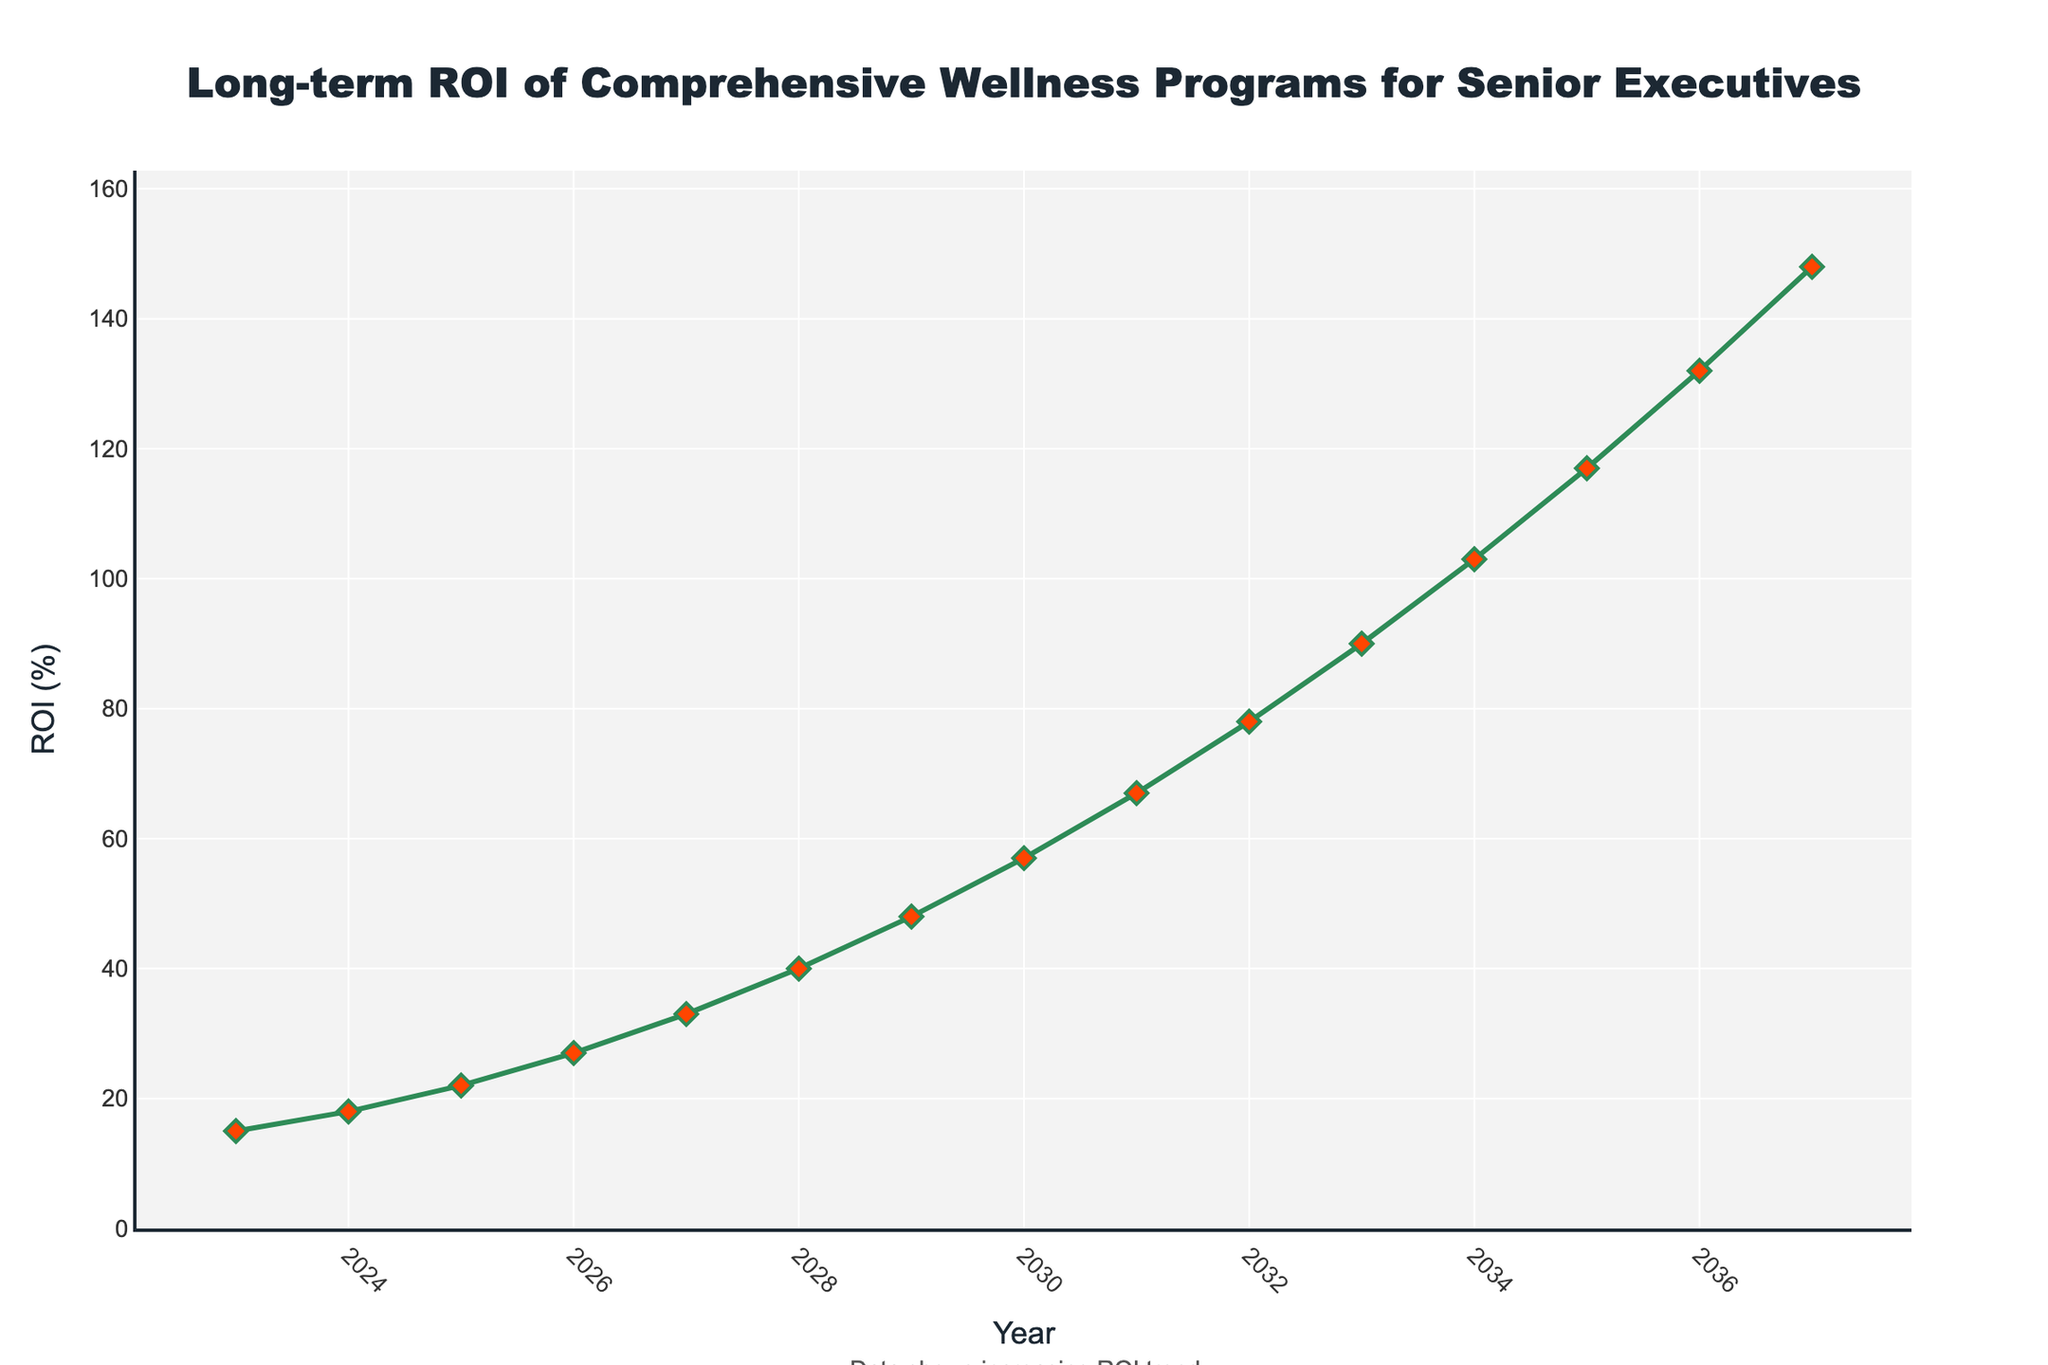What is the ROI in 2028? To find the ROI in 2028, locate the data point on the line chart corresponding to the year 2028. The value on the y-axis for this point shows the ROI (%).
Answer: 40% Which year shows the highest ROI in the data provided? To determine the year with the highest ROI, look for the data point with the maximum y-axis value. The year corresponding to this point shows the highest ROI.
Answer: 2037 How much did the ROI increase between 2025 and 2029? First, find the ROI values in 2025 and 2029 from the chart. Subtract the 2025 value from the 2029 value to calculate the increase. ROI in 2025 = 22%, ROI in 2029 = 48%. Increase = 48% - 22% = 26%.
Answer: 26% What is the average annual ROI growth from 2023 to 2027? Calculate the average growth by subtracting the initial ROI (2023) from the final ROI (2027), then divide by the number of years (2027-2023 = 4 years). ROI in 2023 = 15%, ROI in 2027 = 33%. Growth = 33% - 15% = 18%. Average annual growth = 18% / 4 = 4.5%.
Answer: 4.5% Between which consecutive years is the largest increase in ROI observed? Examine the chart for the largest step between consecutive ROI values. Calculate the increase between each pair of consecutive years to find the largest. The largest increase is between 2033 (90%) and 2034 (103%). Increase = 103% - 90% = 13%.
Answer: 2033 to 2034 What is the median ROI value from 2023 to 2037? Arrange the ROI values in numerical order and identify the middle value. If there's an even number of values, average the two middle values. For 15 values (2023-2037), the median is the 8th value when ordered. Ordered ROIs: [15, 18, 22, 27, 33, 40, 48, 57, 67, 78, 90, 103, 117, 132, 148], median = 57%.
Answer: 57% In which year does the ROI first exceed 100%? Find the first year on the chart where the ROI value crosses the 100% mark. Locate the data point just above 100% on the y-axis. The year is 2034, where ROI = 103%.
Answer: 2034 Is the ROI growth over the given period linear, exponential, or neither? Assess the shape of the curve on the line chart. If the curve appears to be straight and at a constant angle, it is linear. If it curves upwards more sharply over time, it may be exponential. The rapid increase in the latter years suggests an exponential growth pattern.
Answer: Exponential What can you infer from the color of the markers used for the data points? The markers' color is red, which typically stands out and draws attention to each data point on the line chart. The use of red with green lines creates a strong visual contrast, highlighting each year’s ROI clearly.
Answer: Emphasis on data points What visual attribute indicates the continuous trend of increasing ROI over the years? The continuous upward sloping green line connecting the data points indicates a consistently increasing trend in ROI over the years, representing an upward trajectory in wellness programs' ROI.
Answer: Upward sloping line 